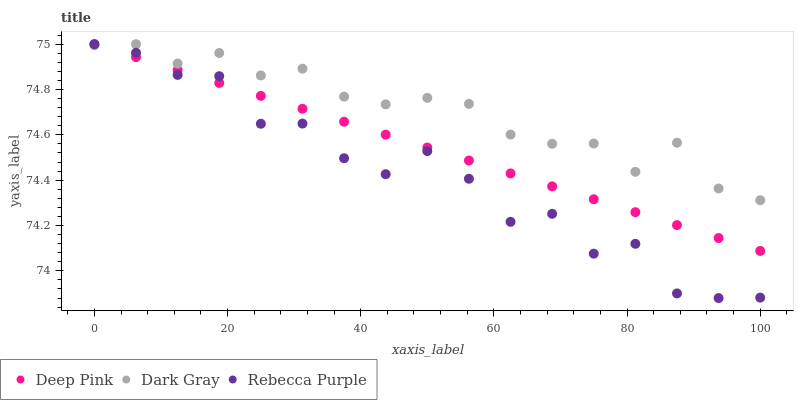Does Rebecca Purple have the minimum area under the curve?
Answer yes or no. Yes. Does Dark Gray have the maximum area under the curve?
Answer yes or no. Yes. Does Deep Pink have the minimum area under the curve?
Answer yes or no. No. Does Deep Pink have the maximum area under the curve?
Answer yes or no. No. Is Deep Pink the smoothest?
Answer yes or no. Yes. Is Rebecca Purple the roughest?
Answer yes or no. Yes. Is Rebecca Purple the smoothest?
Answer yes or no. No. Is Deep Pink the roughest?
Answer yes or no. No. Does Rebecca Purple have the lowest value?
Answer yes or no. Yes. Does Deep Pink have the lowest value?
Answer yes or no. No. Does Rebecca Purple have the highest value?
Answer yes or no. Yes. Does Dark Gray intersect Rebecca Purple?
Answer yes or no. Yes. Is Dark Gray less than Rebecca Purple?
Answer yes or no. No. Is Dark Gray greater than Rebecca Purple?
Answer yes or no. No. 